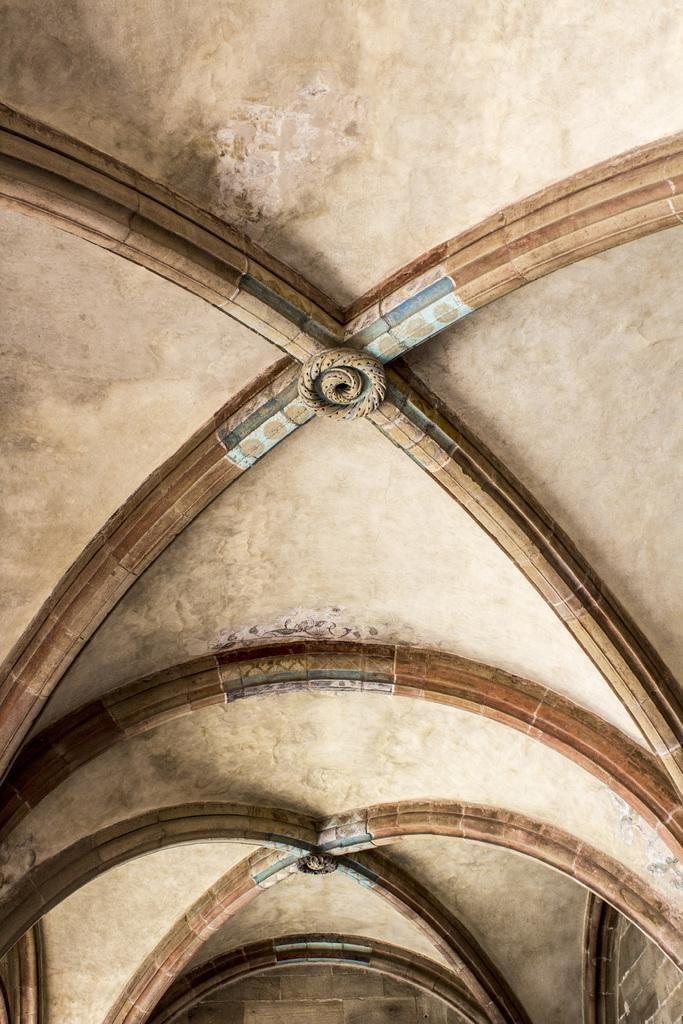What type of location is depicted in the image? The image shows an inside view of a building. What structural elements can be seen in the image? There is a wall and a ceiling visible in the image. What time is displayed on the clock in the image? There is no clock present in the image. Can you describe the coastline visible in the image? The image does not depict a coastline; it shows an inside view of a building. 